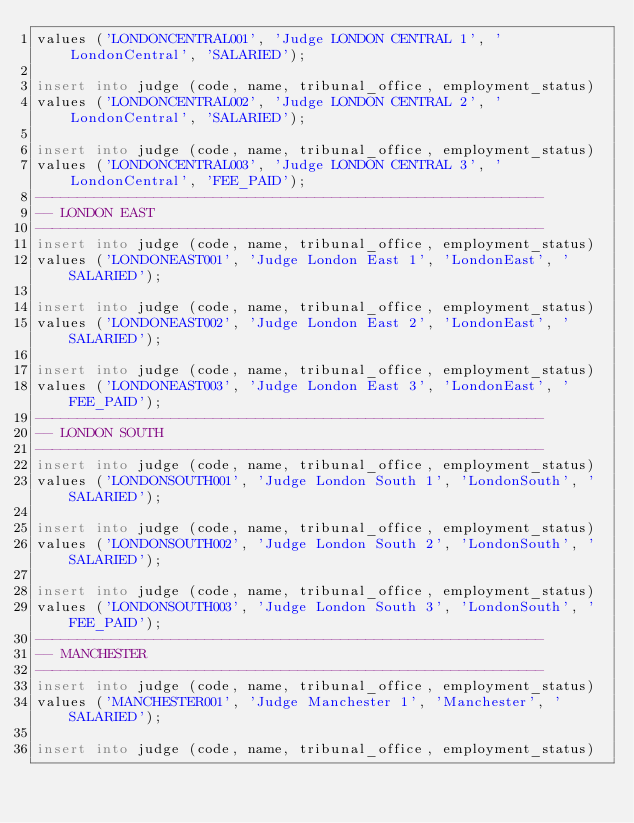Convert code to text. <code><loc_0><loc_0><loc_500><loc_500><_SQL_>values ('LONDONCENTRAL001', 'Judge LONDON CENTRAL 1', 'LondonCentral', 'SALARIED');

insert into judge (code, name, tribunal_office, employment_status)
values ('LONDONCENTRAL002', 'Judge LONDON CENTRAL 2', 'LondonCentral', 'SALARIED');

insert into judge (code, name, tribunal_office, employment_status)
values ('LONDONCENTRAL003', 'Judge LONDON CENTRAL 3', 'LondonCentral', 'FEE_PAID');
------------------------------------------------------------
-- LONDON EAST
------------------------------------------------------------
insert into judge (code, name, tribunal_office, employment_status)
values ('LONDONEAST001', 'Judge London East 1', 'LondonEast', 'SALARIED');

insert into judge (code, name, tribunal_office, employment_status)
values ('LONDONEAST002', 'Judge London East 2', 'LondonEast', 'SALARIED');

insert into judge (code, name, tribunal_office, employment_status)
values ('LONDONEAST003', 'Judge London East 3', 'LondonEast', 'FEE_PAID');
------------------------------------------------------------
-- LONDON SOUTH
------------------------------------------------------------
insert into judge (code, name, tribunal_office, employment_status)
values ('LONDONSOUTH001', 'Judge London South 1', 'LondonSouth', 'SALARIED');

insert into judge (code, name, tribunal_office, employment_status)
values ('LONDONSOUTH002', 'Judge London South 2', 'LondonSouth', 'SALARIED');

insert into judge (code, name, tribunal_office, employment_status)
values ('LONDONSOUTH003', 'Judge London South 3', 'LondonSouth', 'FEE_PAID');
------------------------------------------------------------
-- MANCHESTER
------------------------------------------------------------
insert into judge (code, name, tribunal_office, employment_status)
values ('MANCHESTER001', 'Judge Manchester 1', 'Manchester', 'SALARIED');

insert into judge (code, name, tribunal_office, employment_status)</code> 